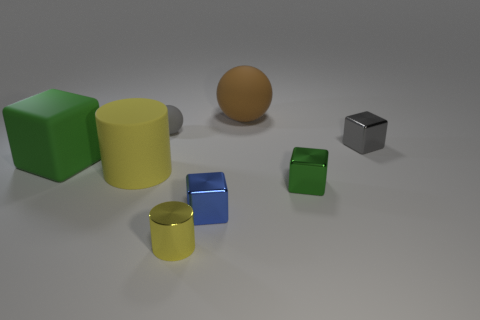How big is the metallic object that is left of the brown thing and behind the small yellow shiny thing?
Provide a short and direct response. Small. Is there a cyan metallic ball that has the same size as the yellow rubber cylinder?
Give a very brief answer. No. Are there more big green cubes that are in front of the tiny green shiny cube than small shiny blocks right of the big brown object?
Offer a terse response. No. Do the blue thing and the big thing that is in front of the rubber cube have the same material?
Ensure brevity in your answer.  No. There is a green object that is on the left side of the yellow cylinder that is to the right of the gray sphere; how many cubes are behind it?
Your response must be concise. 1. There is a tiny green metal thing; is its shape the same as the gray object that is on the right side of the big matte ball?
Your answer should be very brief. Yes. What is the color of the block that is to the left of the tiny green object and in front of the large yellow matte cylinder?
Your response must be concise. Blue. What material is the yellow thing that is to the left of the tiny gray thing that is to the left of the small cube in front of the green metallic cube?
Your response must be concise. Rubber. What is the tiny gray sphere made of?
Ensure brevity in your answer.  Rubber. There is a matte thing that is the same shape as the gray shiny thing; what is its size?
Make the answer very short. Large. 